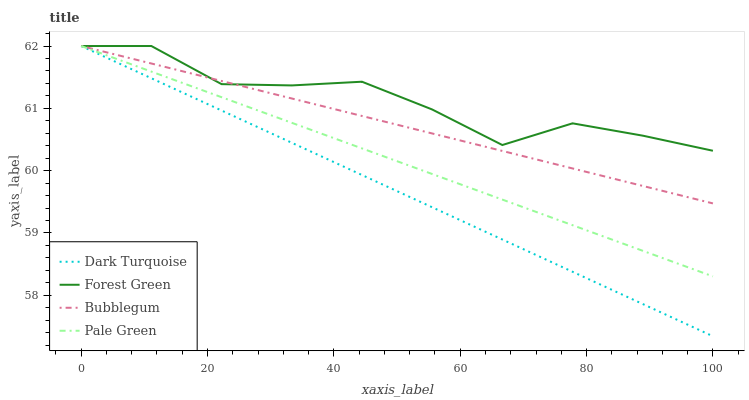Does Dark Turquoise have the minimum area under the curve?
Answer yes or no. Yes. Does Forest Green have the maximum area under the curve?
Answer yes or no. Yes. Does Pale Green have the minimum area under the curve?
Answer yes or no. No. Does Pale Green have the maximum area under the curve?
Answer yes or no. No. Is Pale Green the smoothest?
Answer yes or no. Yes. Is Forest Green the roughest?
Answer yes or no. Yes. Is Forest Green the smoothest?
Answer yes or no. No. Is Pale Green the roughest?
Answer yes or no. No. Does Dark Turquoise have the lowest value?
Answer yes or no. Yes. Does Pale Green have the lowest value?
Answer yes or no. No. Does Bubblegum have the highest value?
Answer yes or no. Yes. Does Dark Turquoise intersect Bubblegum?
Answer yes or no. Yes. Is Dark Turquoise less than Bubblegum?
Answer yes or no. No. Is Dark Turquoise greater than Bubblegum?
Answer yes or no. No. 